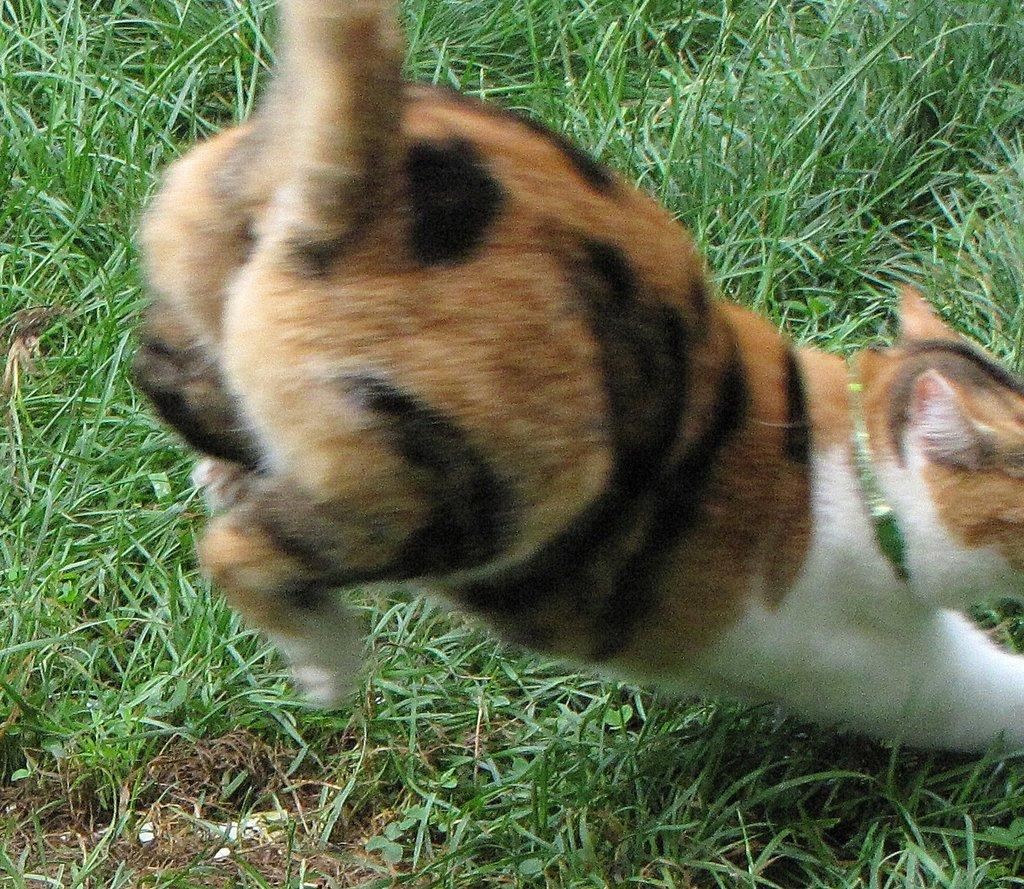What is the main subject of the image? There is a cat in the center of the image. What can be seen in the background of the image? There is grass in the background of the image. What type of brush is the cat using to write a letter in the image? There is no brush or letter present in the image; it features a cat and grass in the background. 